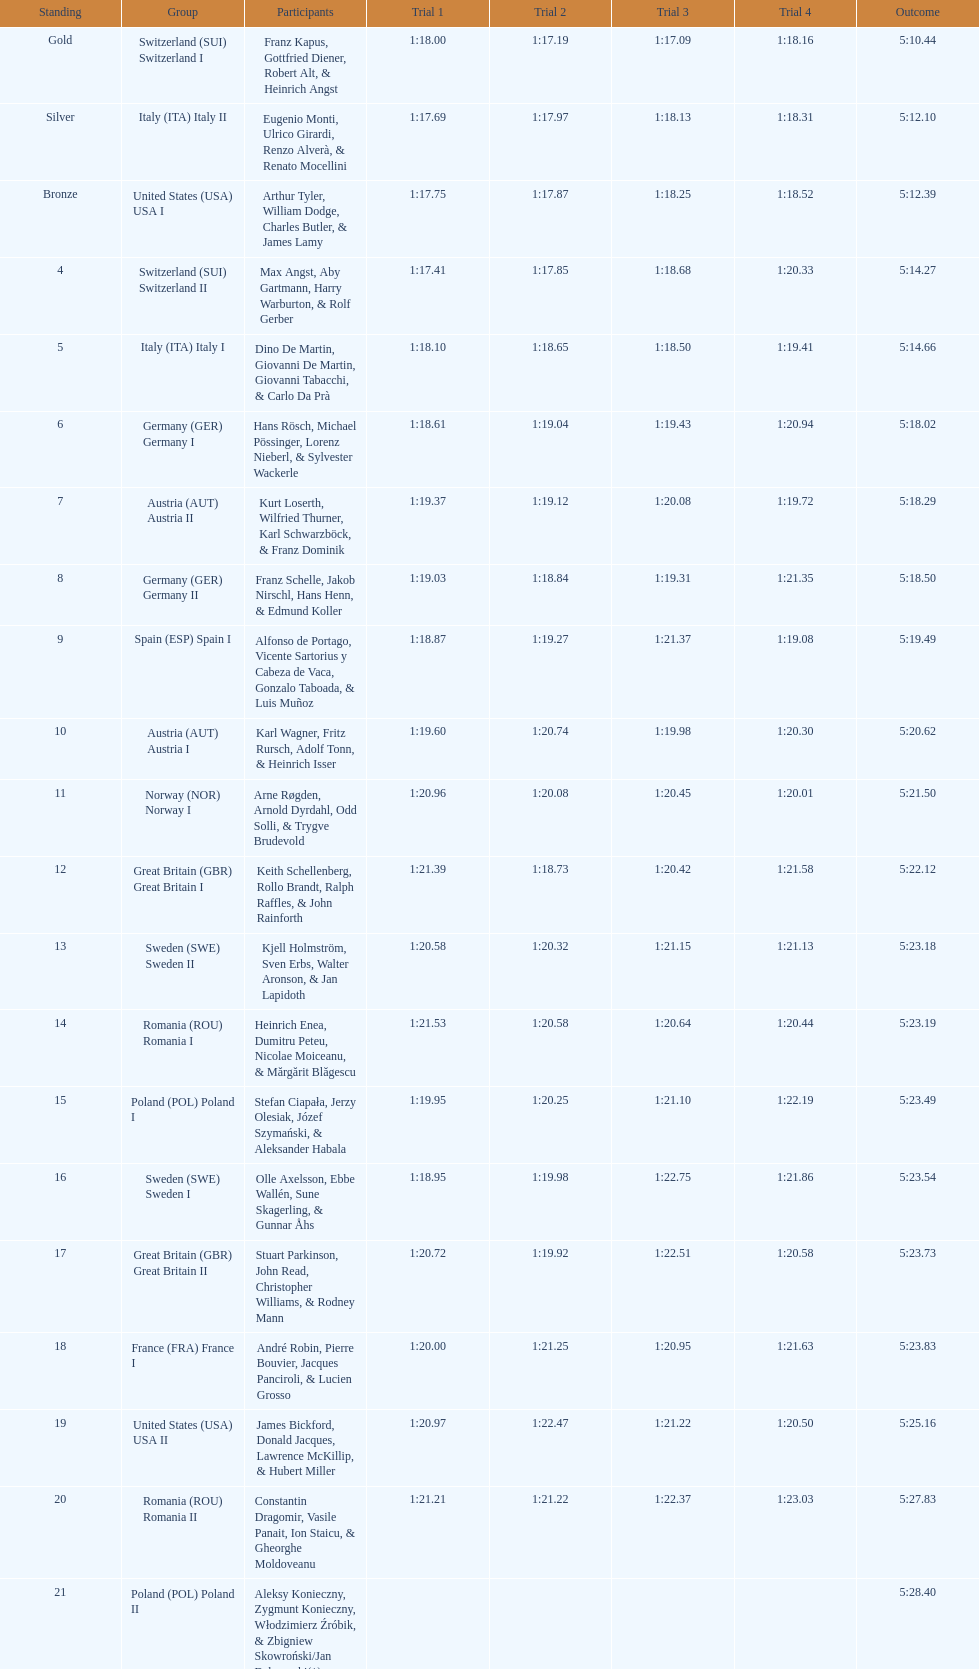What team came out on top? Switzerland. Can you give me this table as a dict? {'header': ['Standing', 'Group', 'Participants', 'Trial 1', 'Trial 2', 'Trial 3', 'Trial 4', 'Outcome'], 'rows': [['Gold', 'Switzerland\xa0(SUI) Switzerland I', 'Franz Kapus, Gottfried Diener, Robert Alt, & Heinrich Angst', '1:18.00', '1:17.19', '1:17.09', '1:18.16', '5:10.44'], ['Silver', 'Italy\xa0(ITA) Italy II', 'Eugenio Monti, Ulrico Girardi, Renzo Alverà, & Renato Mocellini', '1:17.69', '1:17.97', '1:18.13', '1:18.31', '5:12.10'], ['Bronze', 'United States\xa0(USA) USA I', 'Arthur Tyler, William Dodge, Charles Butler, & James Lamy', '1:17.75', '1:17.87', '1:18.25', '1:18.52', '5:12.39'], ['4', 'Switzerland\xa0(SUI) Switzerland II', 'Max Angst, Aby Gartmann, Harry Warburton, & Rolf Gerber', '1:17.41', '1:17.85', '1:18.68', '1:20.33', '5:14.27'], ['5', 'Italy\xa0(ITA) Italy I', 'Dino De Martin, Giovanni De Martin, Giovanni Tabacchi, & Carlo Da Prà', '1:18.10', '1:18.65', '1:18.50', '1:19.41', '5:14.66'], ['6', 'Germany\xa0(GER) Germany I', 'Hans Rösch, Michael Pössinger, Lorenz Nieberl, & Sylvester Wackerle', '1:18.61', '1:19.04', '1:19.43', '1:20.94', '5:18.02'], ['7', 'Austria\xa0(AUT) Austria II', 'Kurt Loserth, Wilfried Thurner, Karl Schwarzböck, & Franz Dominik', '1:19.37', '1:19.12', '1:20.08', '1:19.72', '5:18.29'], ['8', 'Germany\xa0(GER) Germany II', 'Franz Schelle, Jakob Nirschl, Hans Henn, & Edmund Koller', '1:19.03', '1:18.84', '1:19.31', '1:21.35', '5:18.50'], ['9', 'Spain\xa0(ESP) Spain I', 'Alfonso de Portago, Vicente Sartorius y Cabeza de Vaca, Gonzalo Taboada, & Luis Muñoz', '1:18.87', '1:19.27', '1:21.37', '1:19.08', '5:19.49'], ['10', 'Austria\xa0(AUT) Austria I', 'Karl Wagner, Fritz Rursch, Adolf Tonn, & Heinrich Isser', '1:19.60', '1:20.74', '1:19.98', '1:20.30', '5:20.62'], ['11', 'Norway\xa0(NOR) Norway I', 'Arne Røgden, Arnold Dyrdahl, Odd Solli, & Trygve Brudevold', '1:20.96', '1:20.08', '1:20.45', '1:20.01', '5:21.50'], ['12', 'Great Britain\xa0(GBR) Great Britain I', 'Keith Schellenberg, Rollo Brandt, Ralph Raffles, & John Rainforth', '1:21.39', '1:18.73', '1:20.42', '1:21.58', '5:22.12'], ['13', 'Sweden\xa0(SWE) Sweden II', 'Kjell Holmström, Sven Erbs, Walter Aronson, & Jan Lapidoth', '1:20.58', '1:20.32', '1:21.15', '1:21.13', '5:23.18'], ['14', 'Romania\xa0(ROU) Romania I', 'Heinrich Enea, Dumitru Peteu, Nicolae Moiceanu, & Mărgărit Blăgescu', '1:21.53', '1:20.58', '1:20.64', '1:20.44', '5:23.19'], ['15', 'Poland\xa0(POL) Poland I', 'Stefan Ciapała, Jerzy Olesiak, Józef Szymański, & Aleksander Habala', '1:19.95', '1:20.25', '1:21.10', '1:22.19', '5:23.49'], ['16', 'Sweden\xa0(SWE) Sweden I', 'Olle Axelsson, Ebbe Wallén, Sune Skagerling, & Gunnar Åhs', '1:18.95', '1:19.98', '1:22.75', '1:21.86', '5:23.54'], ['17', 'Great Britain\xa0(GBR) Great Britain II', 'Stuart Parkinson, John Read, Christopher Williams, & Rodney Mann', '1:20.72', '1:19.92', '1:22.51', '1:20.58', '5:23.73'], ['18', 'France\xa0(FRA) France I', 'André Robin, Pierre Bouvier, Jacques Panciroli, & Lucien Grosso', '1:20.00', '1:21.25', '1:20.95', '1:21.63', '5:23.83'], ['19', 'United States\xa0(USA) USA II', 'James Bickford, Donald Jacques, Lawrence McKillip, & Hubert Miller', '1:20.97', '1:22.47', '1:21.22', '1:20.50', '5:25.16'], ['20', 'Romania\xa0(ROU) Romania II', 'Constantin Dragomir, Vasile Panait, Ion Staicu, & Gheorghe Moldoveanu', '1:21.21', '1:21.22', '1:22.37', '1:23.03', '5:27.83'], ['21', 'Poland\xa0(POL) Poland II', 'Aleksy Konieczny, Zygmunt Konieczny, Włodzimierz Źróbik, & Zbigniew Skowroński/Jan Dąbrowski(*)', '', '', '', '', '5:28.40']]} 